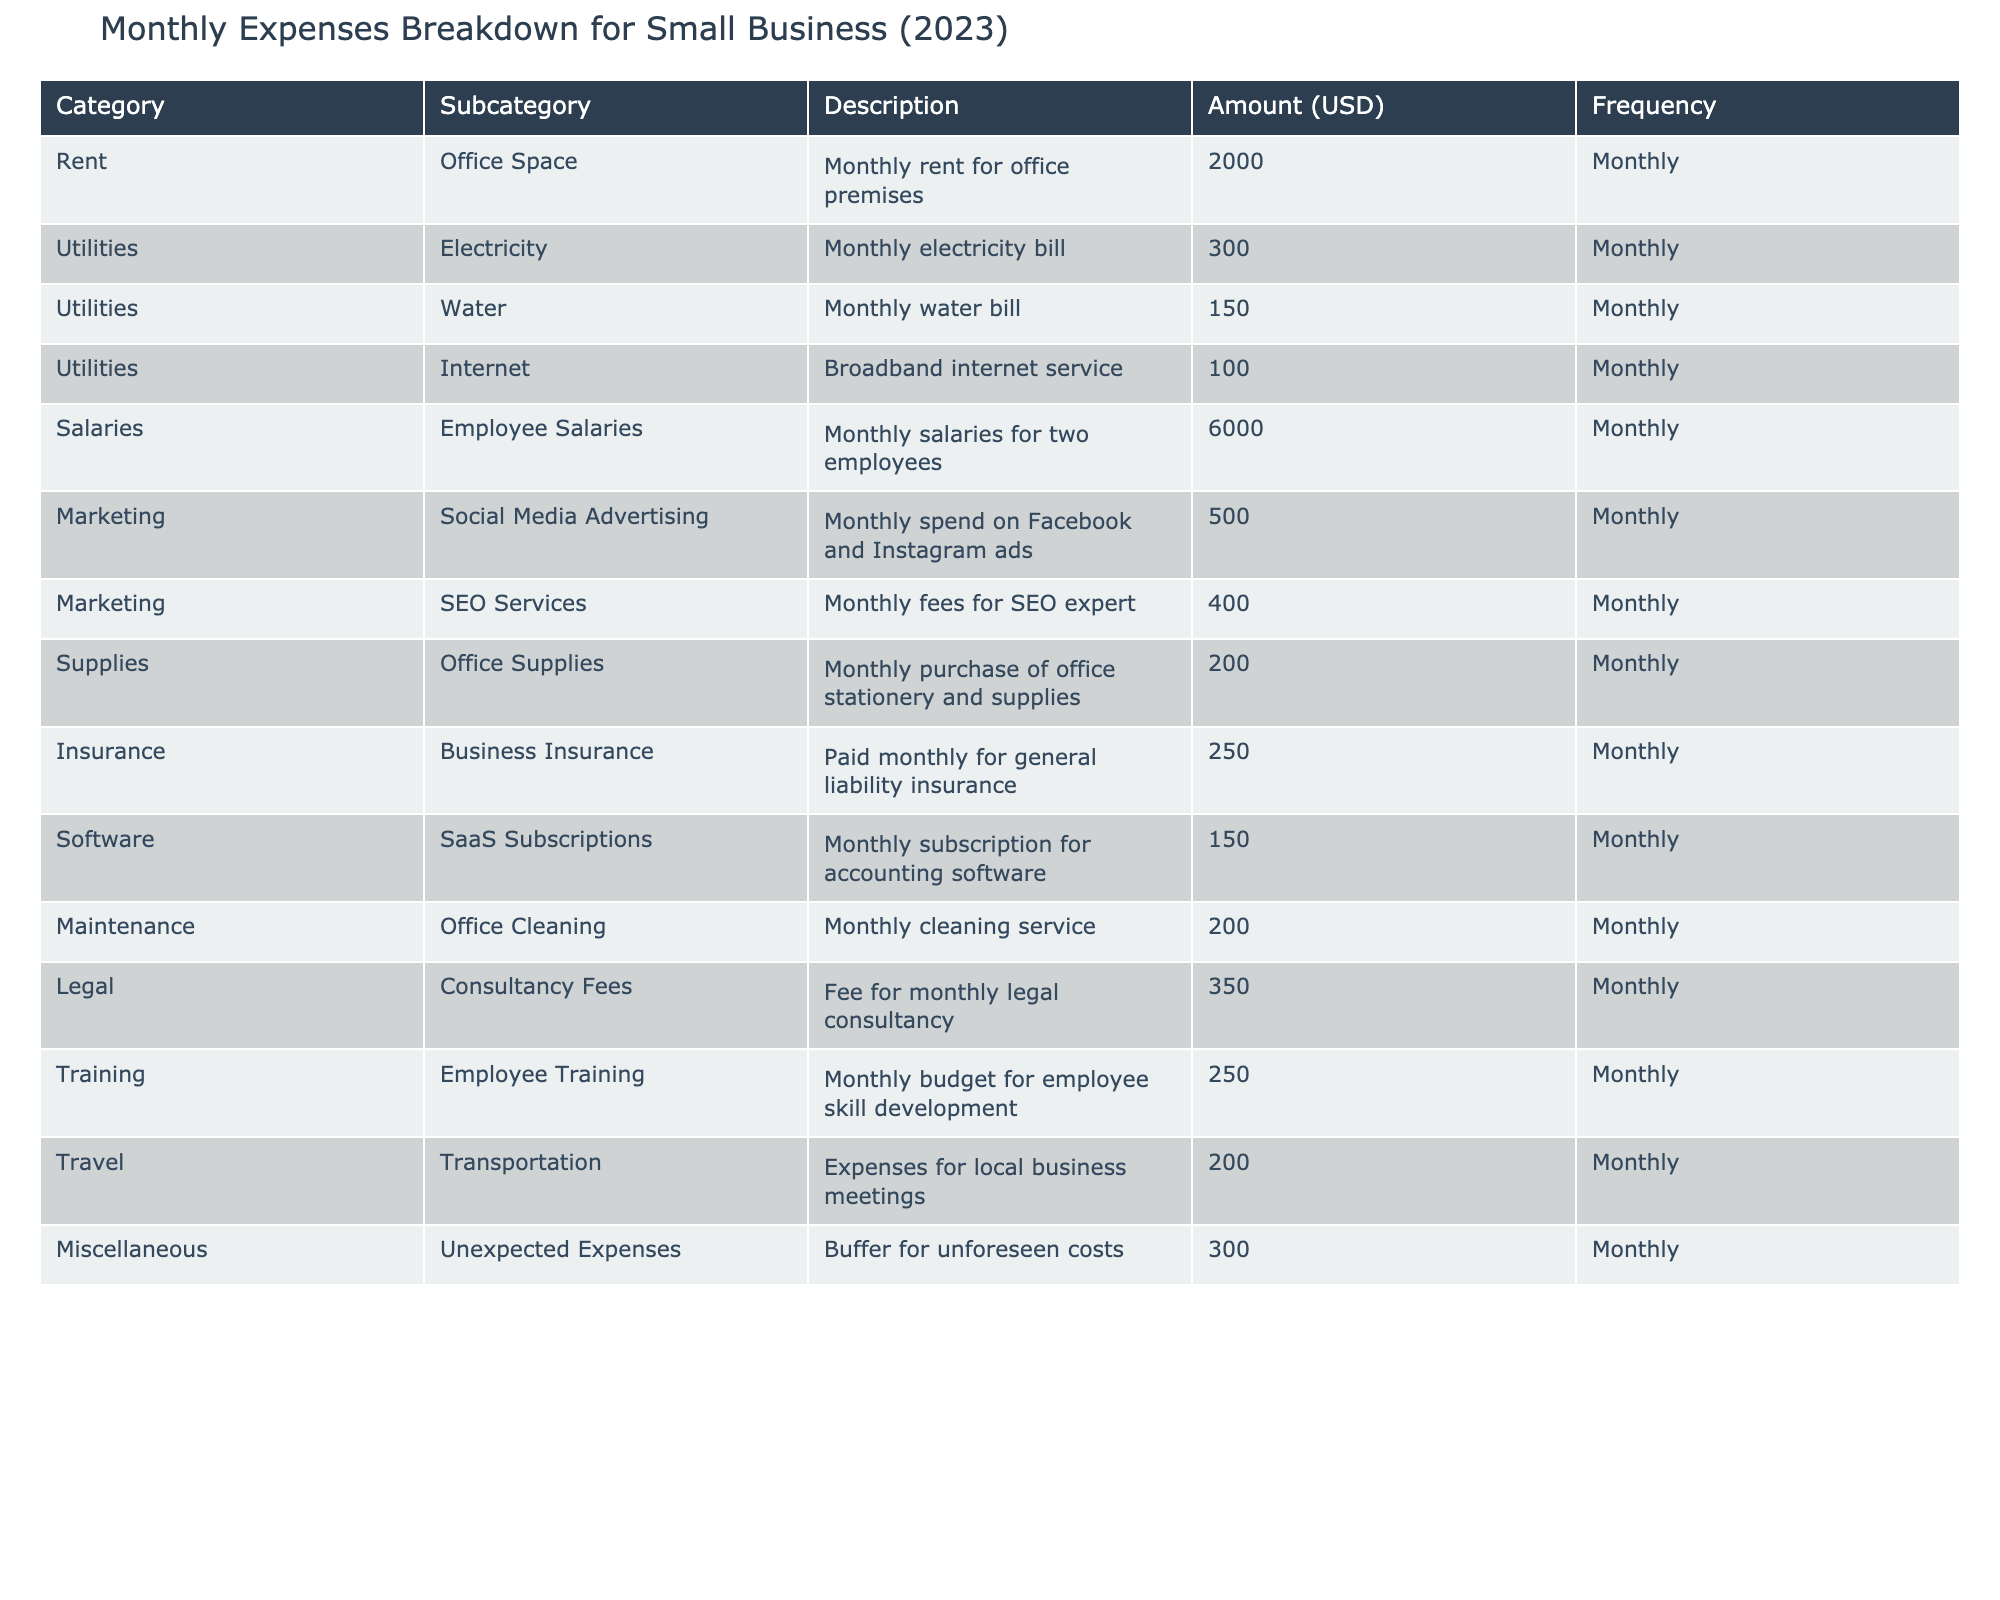What is the total amount spent on utilities each month? The utilities category includes three subcategories: Electricity ($300), Water ($150), and Internet ($100). Adding these amounts together gives us: 300 + 150 + 100 = 550.
Answer: 550 What is the amount allocated for employee salaries per month? The table lists Employee Salaries under the Salaries category, which amounts to $6000 monthly.
Answer: 6000 Is the monthly expense for marketing more than $800? The marketing category includes Social Media Advertising ($500) and SEO Services ($400). Adding these amounts gives us: 500 + 400 = 900, which is greater than 800.
Answer: Yes What is the average monthly cost for supplies, insurance, and maintenance combined? The amounts for supplies, insurance, and maintenance are: Office Supplies ($200), Business Insurance ($250), and Office Cleaning ($200). First, we sum these values: 200 + 250 + 200 = 650. Then, we calculate the average by dividing by 3 (the number of items): 650 / 3 = 216.67.
Answer: 216.67 How much is spent monthly on miscellaneous expenses? The miscellaneous expenses are listed as Unexpected Expenses, costing $300 each month.
Answer: 300 Is there a higher expense in the Marketing category than in the Utilities category? The Marketing category total is $900 (500 + 400) and the Utilities category total is $550 (300 + 150 + 100). Since $900 is greater than $550, the answer is yes.
Answer: Yes What are the total monthly expenses for all categories listed? To find the total, we need to add all individual amounts in the table: 2000 (Rent) + 550 (Utilities) + 6000 (Salaries) + 900 (Marketing) + 200 (Supplies) + 250 (Insurance) + 150 (Software) + 200 (Maintenance) + 350 (Legal) + 250 (Training) + 200 (Travel) + 300 (Miscellaneous) = 8570.
Answer: 8570 How much more is spent on employee salaries than on legal consultancy fees? Employee salaries cost $6000 while legal consultancy fees are $350. To find the difference, we subtract: 6000 - 350 = 5650.
Answer: 5650 